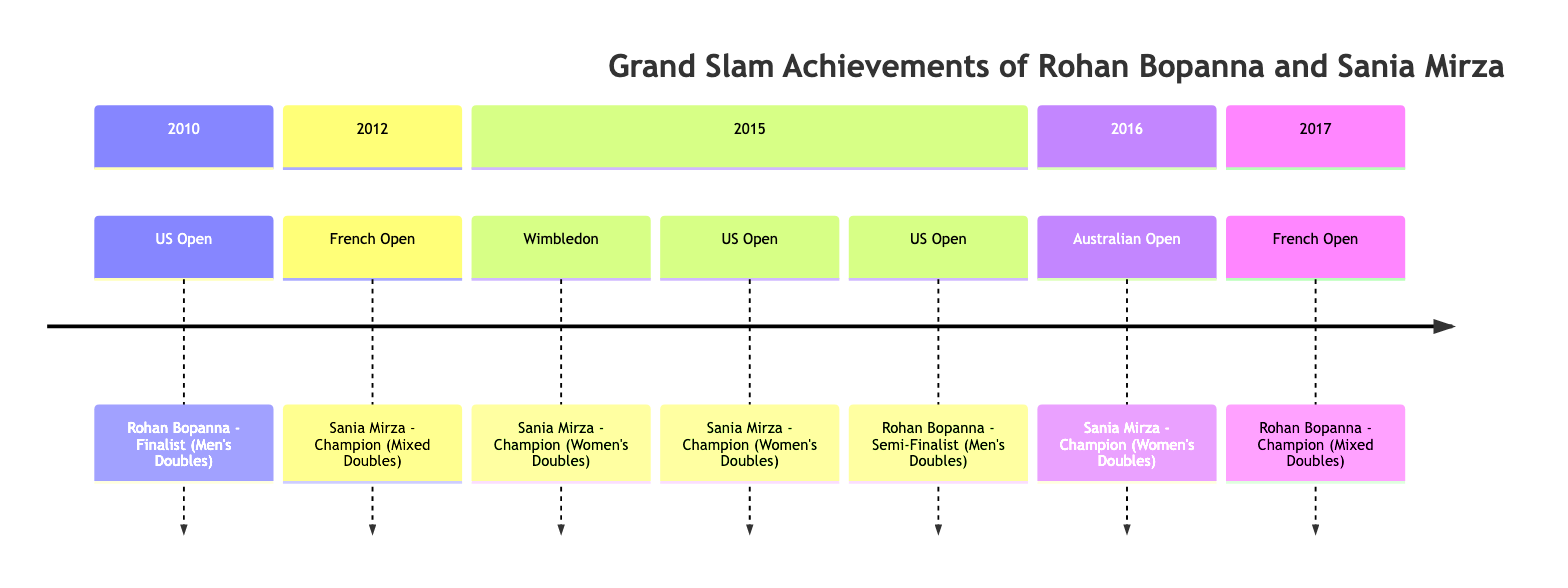What's the first Grand Slam achievement listed for Rohan Bopanna? The diagram indicates Rohan Bopanna was a finalist at the US Open in 2010, which is the first achievement shown.
Answer: Finalist (Men's Doubles) How many Grand Slam championships did Sania Mirza win according to the timeline? The timeline shows Sania Mirza winning a total of three championships: one at the French Open in 2012, one at Wimbledon in 2015, and two at the US Open in 2015, adding up to four achievements.
Answer: 4 Who achieved a Grand Slam championship in the year 2015? The diagram reveals that both Sania Mirza and Rohan Bopanna had relevant achievements in 2015; however, Sania Mirza won two championships in Women's Doubles and Rohan Bopanna was a semi-finalist in Men's Doubles.
Answer: Sania Mirza Which Grand Slam tournament did Rohan Bopanna win? Rohan Bopanna is listed as the champion of Mixed Doubles at the French Open in 2017 according to the timeline.
Answer: French Open In what year did Sania Mirza win her first Women's Doubles Grand Slam? The diagram illustrates that Sania Mirza won her first Women's Doubles Grand Slam at Wimbledon in 2015, which was the earliest achievement for her in that category.
Answer: 2015 How many times did Sania Mirza compete in the US Open according to the timeline? Sania Mirza competed in the US Open three times according to the timeline, once in 2015 for Women's Doubles and she is also a champion in that context, following the two instances as a champion listed in 2015.
Answer: 2 What is the significant achievement Rohan Bopanna accomplished in 2017? The timeline states that in 2017, Rohan Bopanna won the Mixed Doubles title at the French Open, which marks a high point in his achievements.
Answer: Champion (Mixed Doubles) What does the timeline indicate about Sania Mirza's performance in Grand Slams in 2016? According to the diagram, Sania Mirza's only achievement in 2016 was winning the Women's Doubles title at the Australian Open.
Answer: Champion (Women's Doubles) 